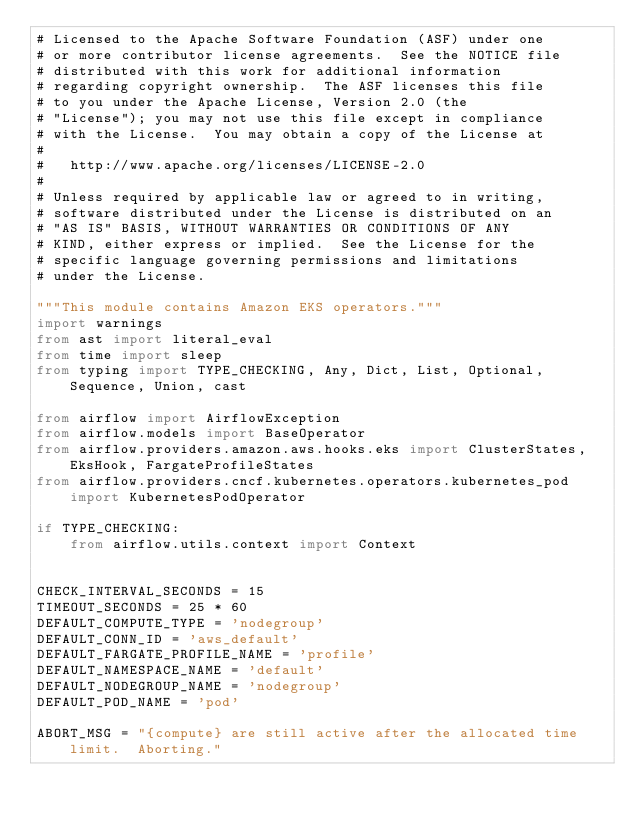Convert code to text. <code><loc_0><loc_0><loc_500><loc_500><_Python_># Licensed to the Apache Software Foundation (ASF) under one
# or more contributor license agreements.  See the NOTICE file
# distributed with this work for additional information
# regarding copyright ownership.  The ASF licenses this file
# to you under the Apache License, Version 2.0 (the
# "License"); you may not use this file except in compliance
# with the License.  You may obtain a copy of the License at
#
#   http://www.apache.org/licenses/LICENSE-2.0
#
# Unless required by applicable law or agreed to in writing,
# software distributed under the License is distributed on an
# "AS IS" BASIS, WITHOUT WARRANTIES OR CONDITIONS OF ANY
# KIND, either express or implied.  See the License for the
# specific language governing permissions and limitations
# under the License.

"""This module contains Amazon EKS operators."""
import warnings
from ast import literal_eval
from time import sleep
from typing import TYPE_CHECKING, Any, Dict, List, Optional, Sequence, Union, cast

from airflow import AirflowException
from airflow.models import BaseOperator
from airflow.providers.amazon.aws.hooks.eks import ClusterStates, EksHook, FargateProfileStates
from airflow.providers.cncf.kubernetes.operators.kubernetes_pod import KubernetesPodOperator

if TYPE_CHECKING:
    from airflow.utils.context import Context


CHECK_INTERVAL_SECONDS = 15
TIMEOUT_SECONDS = 25 * 60
DEFAULT_COMPUTE_TYPE = 'nodegroup'
DEFAULT_CONN_ID = 'aws_default'
DEFAULT_FARGATE_PROFILE_NAME = 'profile'
DEFAULT_NAMESPACE_NAME = 'default'
DEFAULT_NODEGROUP_NAME = 'nodegroup'
DEFAULT_POD_NAME = 'pod'

ABORT_MSG = "{compute} are still active after the allocated time limit.  Aborting."</code> 